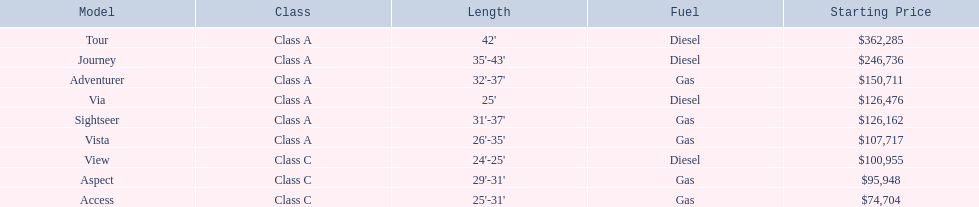Is the diesel model the tour or the aspect? Tour. 